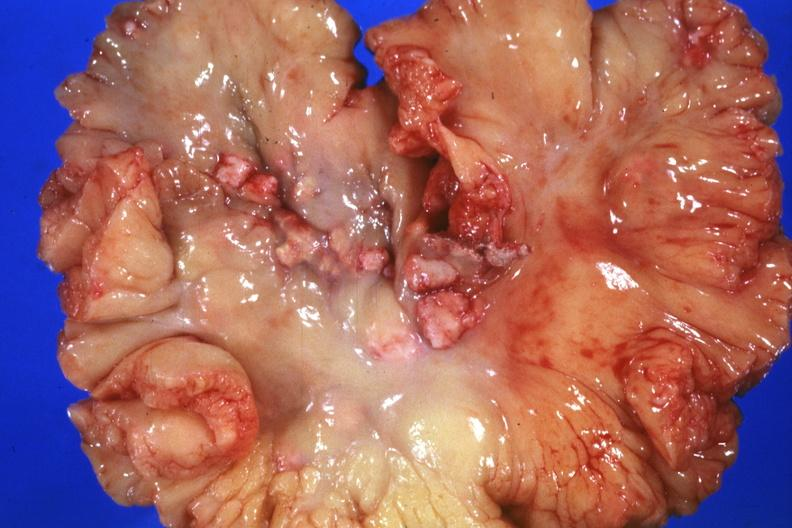what is present?
Answer the question using a single word or phrase. Metastatic carcinoma breast 